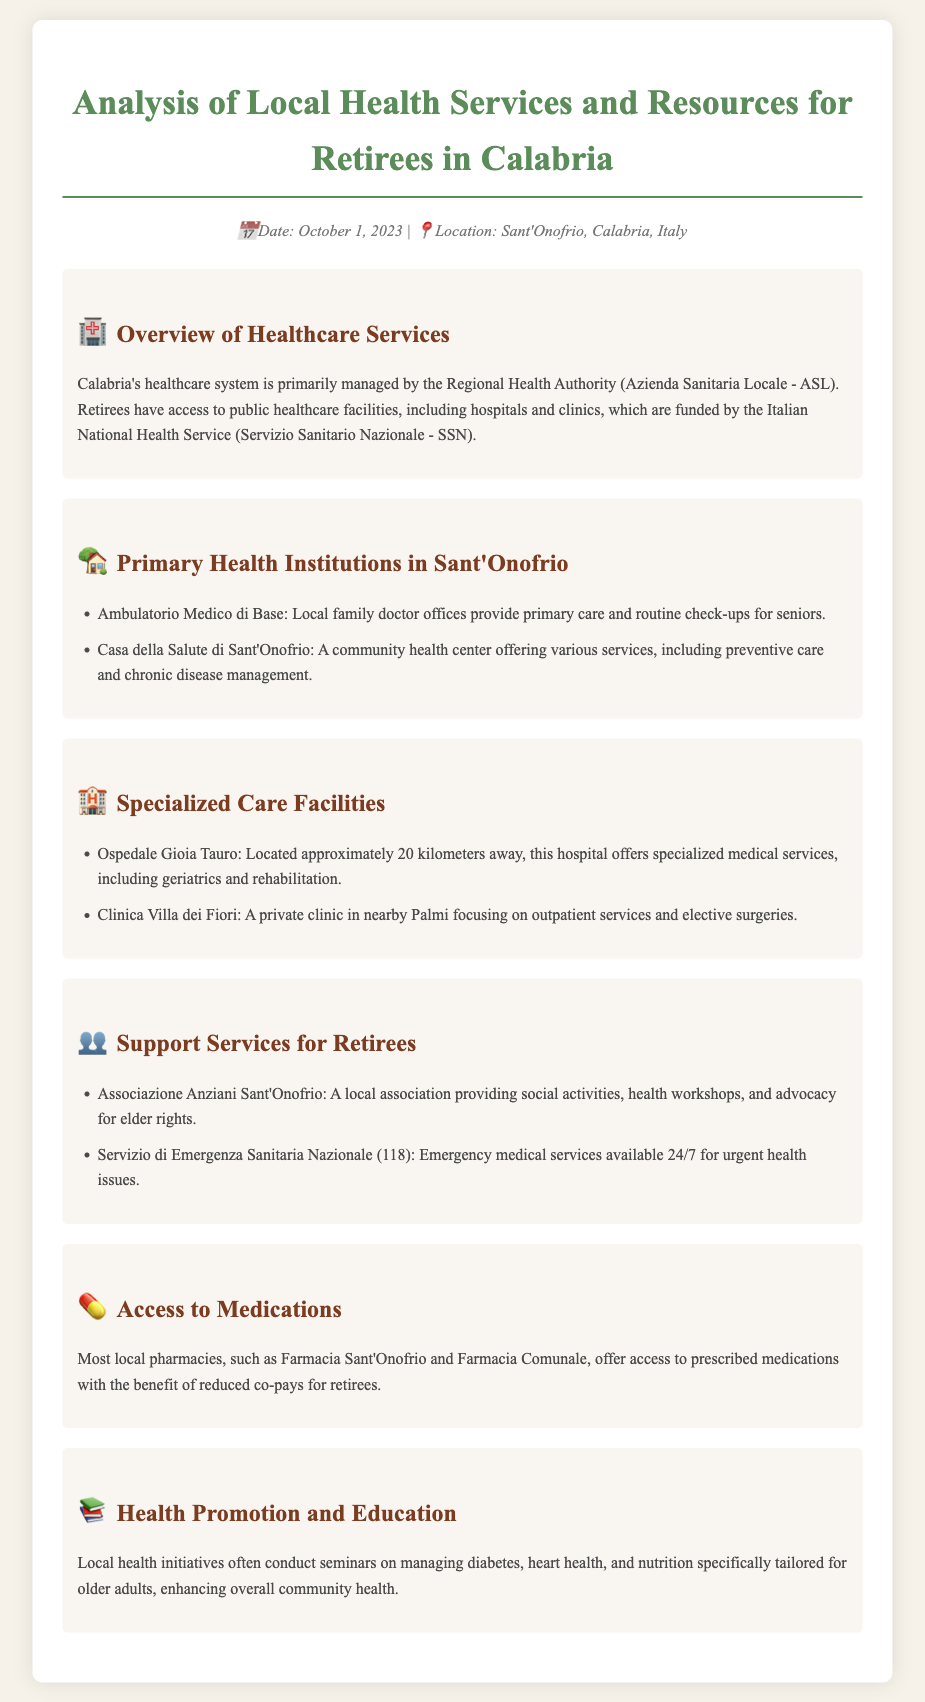What is the title of the document? The title of the document is explicitly stated at the top of the rendered document.
Answer: Analysis of Local Health Services and Resources for Retirees in Calabria What is the location of the health services analysis? The location is mentioned in the meta section of the document, indicating where the analysis is focused.
Answer: Sant'Onofrio, Calabria, Italy What two primary health institutions are mentioned in Sant'Onofrio? The document lists specific institutions under the relevant section, providing details on local health services.
Answer: Ambulatorio Medico di Base, Casa della Salute di Sant'Onofrio How far is Ospedale Gioia Tauro from Sant'Onofrio? The distance is noted in the specialized care facilities section, giving context to the proximity of medical services.
Answer: Approximately 20 kilometers What emergency service is available for urgent health issues? The document specifies a dedicated emergency service available to retirees for urgent health matters.
Answer: Servizio di Emergenza Sanitaria Nazionale (118) What type of health promotion initiatives are conducted locally? The health promotion section mentions specific seminars aimed at enhancing community health for seniors.
Answer: Seminars on managing diabetes, heart health, and nutrition Which local association provides social activities for seniors? This information is found in the support services for retirees section, showcasing community involvement.
Answer: Associazione Anziani Sant'Onofrio What benefit do retirees receive at local pharmacies? The document describes benefits available to retirees in relation to medication access and costs.
Answer: Reduced co-pays for retirees 